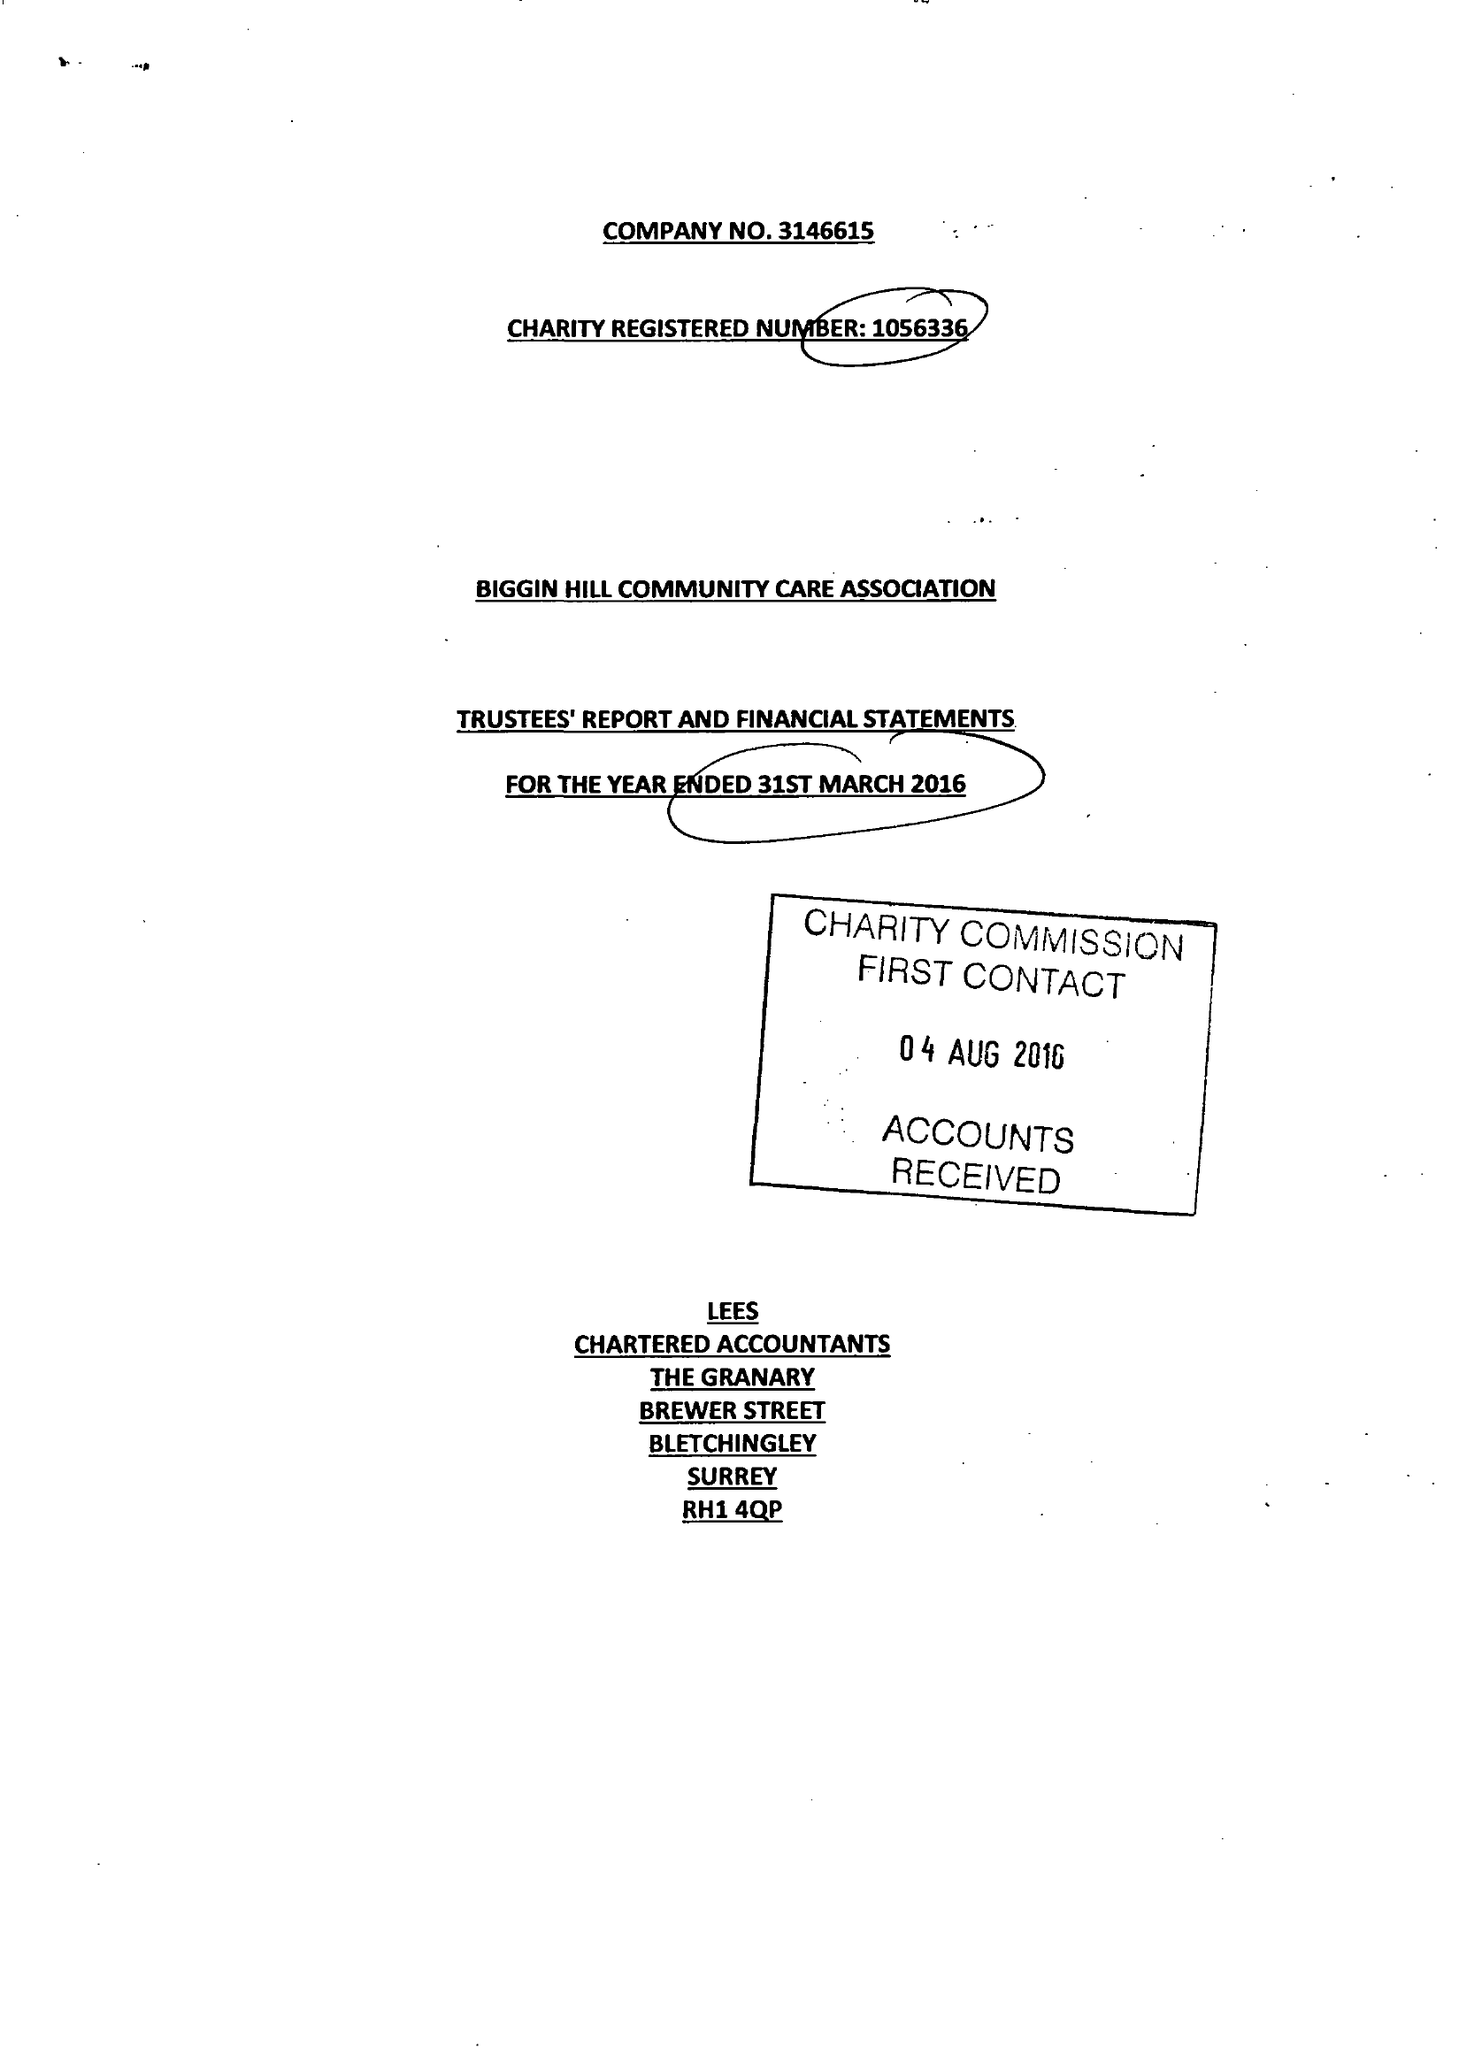What is the value for the spending_annually_in_british_pounds?
Answer the question using a single word or phrase. 79412.00 